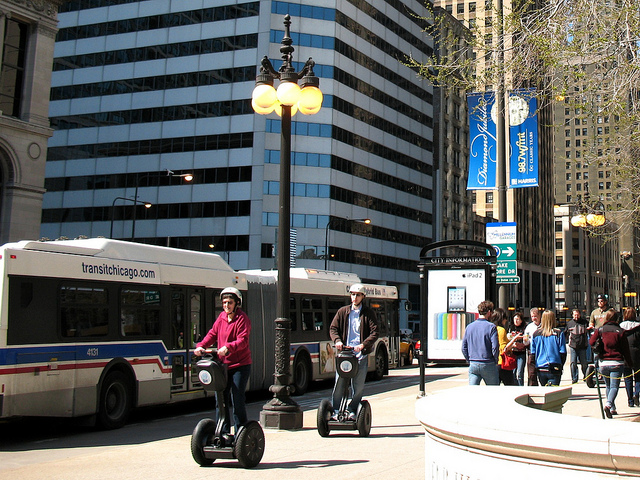<image>Why are they riding on the street? It is unknown why they are riding on the street. Why are they riding on the street? I don't know why they are riding on the street. It can be for various reasons such as touring, patrolling, or because there is too much traffic. 